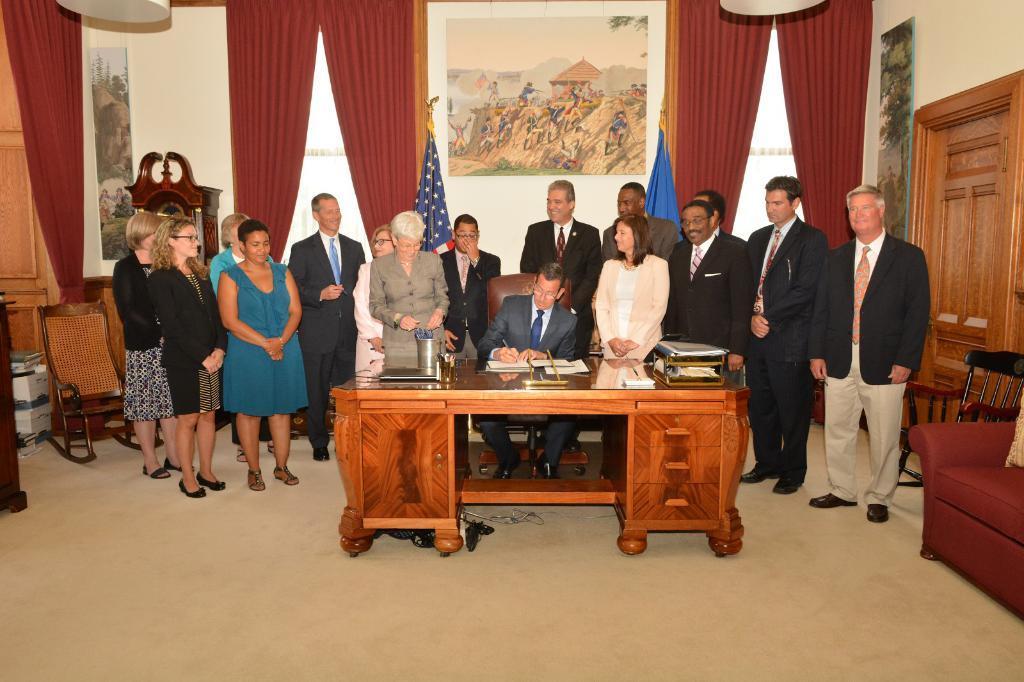Please provide a concise description of this image. In the image we can see there are people who are standing and a person is sitting on chair and on table there are files, book, paper, pen stand, laptop and at the back there are curtains which are in red colour and on wall there is photo frame and portrait. 